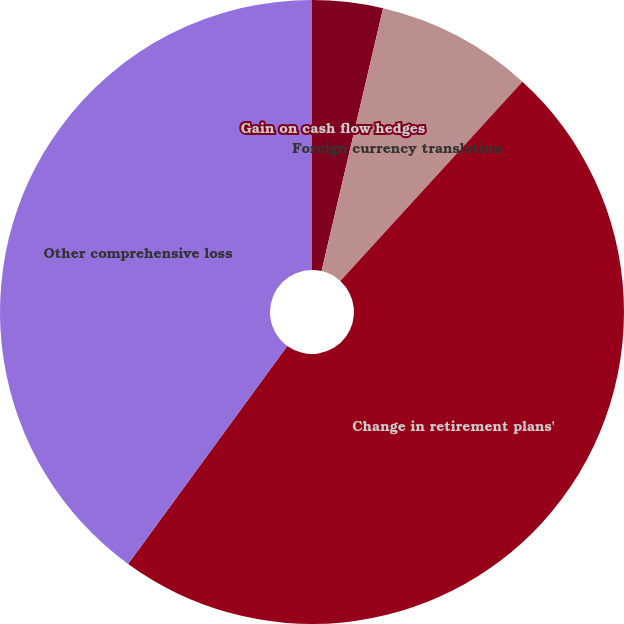Convert chart. <chart><loc_0><loc_0><loc_500><loc_500><pie_chart><fcel>Gain on cash flow hedges<fcel>Foreign currency translation<fcel>Change in retirement plans'<fcel>Other comprehensive loss<nl><fcel>3.66%<fcel>8.12%<fcel>48.25%<fcel>39.97%<nl></chart> 